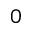Convert formula to latex. <formula><loc_0><loc_0><loc_500><loc_500>0</formula> 